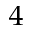<formula> <loc_0><loc_0><loc_500><loc_500>_ { 4 }</formula> 